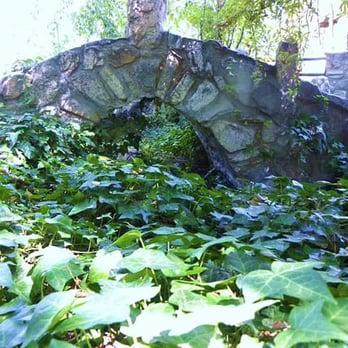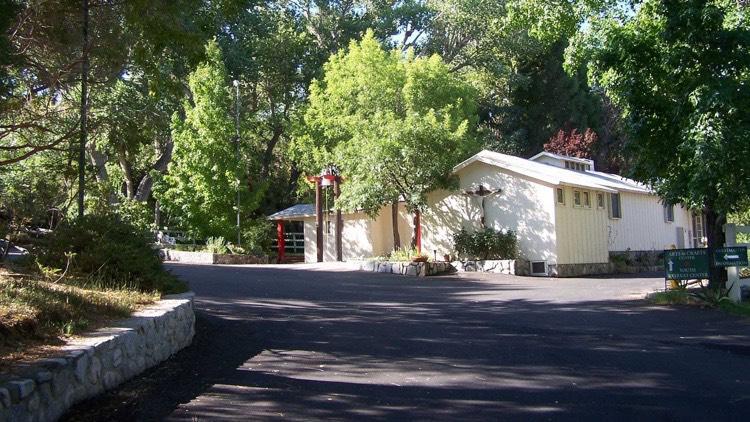The first image is the image on the left, the second image is the image on the right. Evaluate the accuracy of this statement regarding the images: "There is a body of water on the images.". Is it true? Answer yes or no. No. 